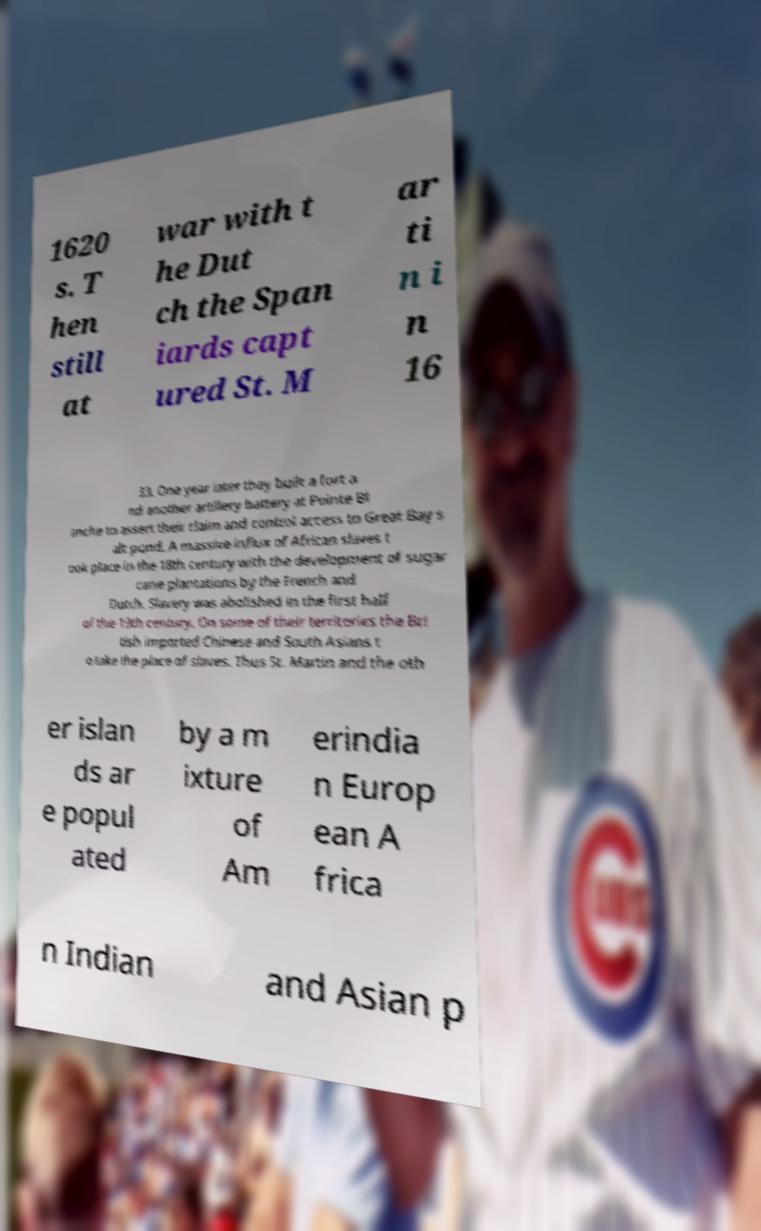Please identify and transcribe the text found in this image. 1620 s. T hen still at war with t he Dut ch the Span iards capt ured St. M ar ti n i n 16 33. One year later they built a fort a nd another artillery battery at Pointe Bl anche to assert their claim and control access to Great Bay s alt pond. A massive influx of African slaves t ook place in the 18th century with the development of sugar cane plantations by the French and Dutch. Slavery was abolished in the first half of the 19th century. On some of their territories the Bri tish imported Chinese and South Asians t o take the place of slaves. Thus St. Martin and the oth er islan ds ar e popul ated by a m ixture of Am erindia n Europ ean A frica n Indian and Asian p 